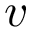<formula> <loc_0><loc_0><loc_500><loc_500>v</formula> 